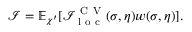Convert formula to latex. <formula><loc_0><loc_0><loc_500><loc_500>\mathcal { I } = \mathbb { E } _ { \chi ^ { \prime } } [ \mathcal { I } _ { l o c } ^ { C V } ( \sigma , \eta ) w ( \sigma , \eta ) ] .</formula> 